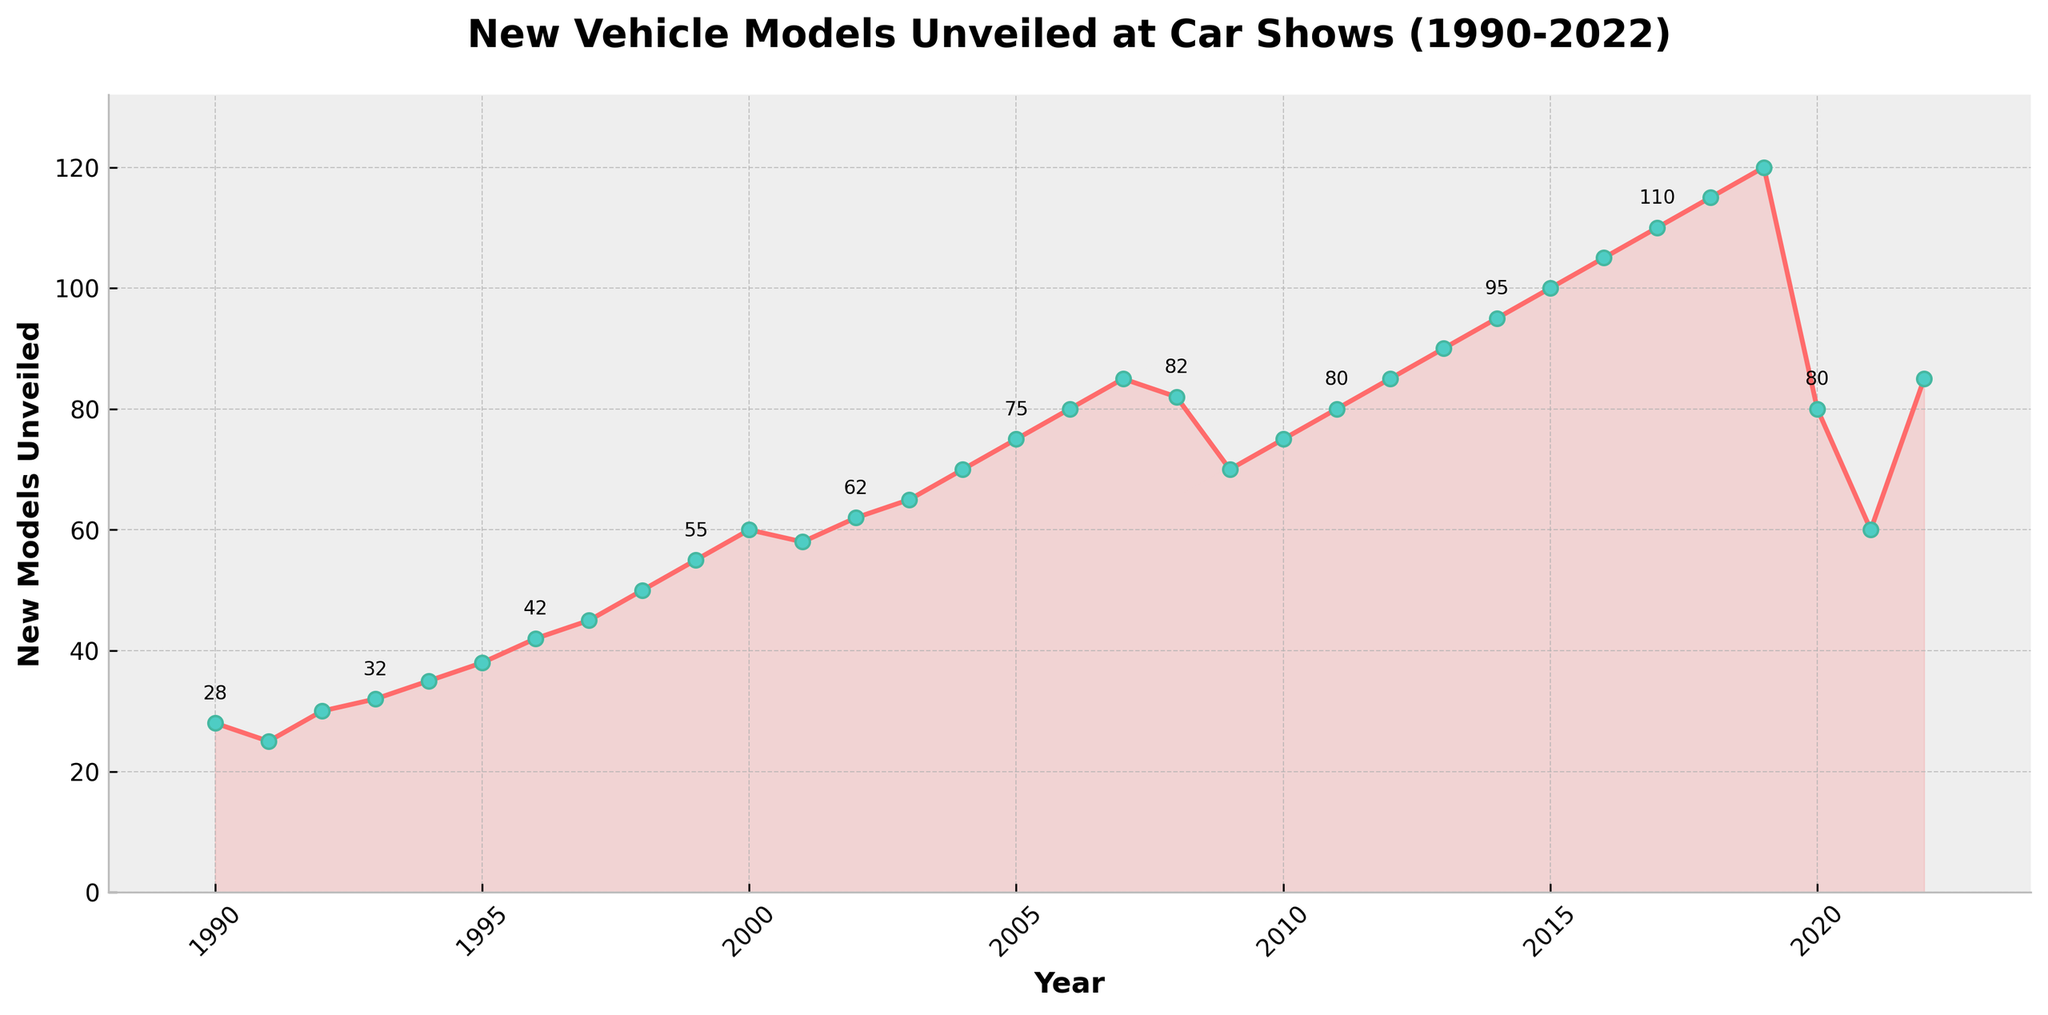What's the overall trend in the number of new vehicle models unveiled from 1990 to 2022? The trend shows a general increase from 1990 to 2019, peaking at 120 models in 2019, followed by a sharp decline in 2020 and 2021, and a slight recovery in 2022.
Answer: Increasing until 2019, then decreasing and recovering slightly in 2022 Which year had the highest number of new vehicle models unveiled? By observing the peak in the chart, 2019 had the highest number of new vehicle models unveiled, with 120.
Answer: 2019 How many new vehicle models were unveiled in the year 2000? Locate the point on the line chart corresponding to the year 2000 and observe the value, which is 60.
Answer: 60 What is the difference in the number of new models unveiled between 2019 and 2020? The number of new models unveiled in 2019 was 120 and in 2020 it was 80. The difference is 120 - 80 = 40.
Answer: 40 Between which two consecutive years did the largest decrease in new models unveiled occur? The largest decrease in new models unveiled is observed between 2019 (120) and 2020 (80), a difference of 40 models.
Answer: 2019 and 2020 Describe the trend during the 2008 financial crisis period. The number of new models increased up to 2007 (85) and then decreased sharply in 2008 and 2009 to 70 models, showing a recovery trend again in 2010.
Answer: Sharp decrease from 2007 to 2009 What are the visual attributes of the plot line and markers? The plot line is displayed with a red color, the markers are green filled circles with a black edge, and there are labels for some data points at regular intervals.
Answer: The plot line is red with green filled markers What is the average number of new vehicle models unveiled between 2000-2010? Sum the values from 2000 to 2010: 60 + 58 + 62 + 65 + 70 + 75 + 80 + 85 + 82 + 70 + 75 = 782. The average is 782 / 11 = 71.1.
Answer: 71.1 How did the number of new models change from the year 2000 to 2022? Compare 2000 (60 models) and 2022 (85 models). The change is an increase of 85 - 60 = 25 models.
Answer: Increased by 25 models How did the number of new vehicle models unveiled change between 2016 and 2017? In 2016, 105 models were unveiled and in 2017, 110 were unveiled. The increase is 110 - 105 = 5 models.
Answer: Increased by 5 models 